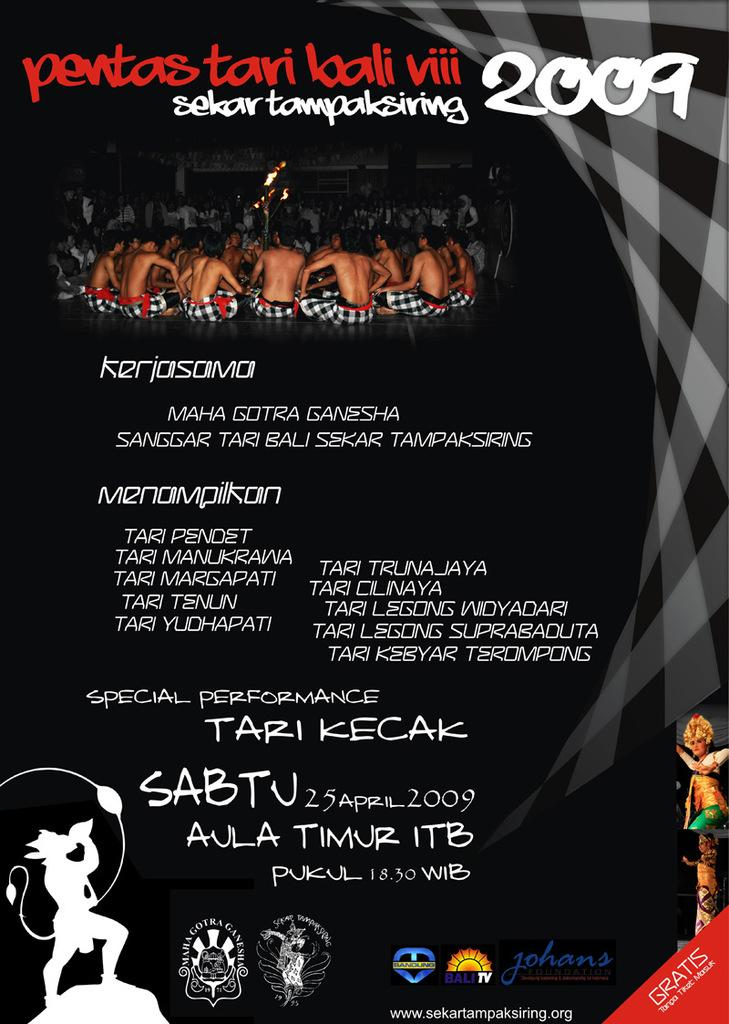<image>
Write a terse but informative summary of the picture. black and white poster for pentas tari loali viii 2009 with a photo of shirtless men gathered around 